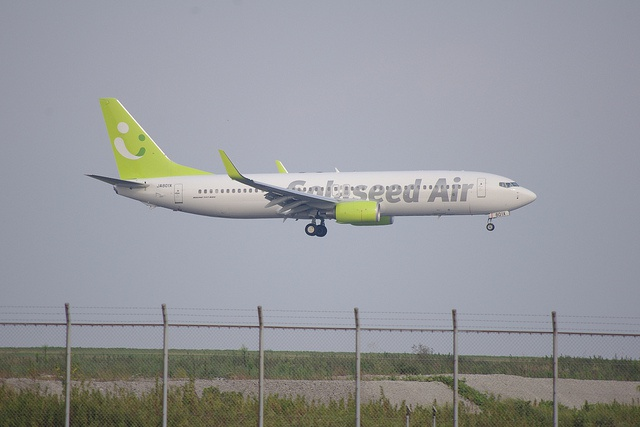Describe the objects in this image and their specific colors. I can see a airplane in gray, darkgray, lightgray, and khaki tones in this image. 